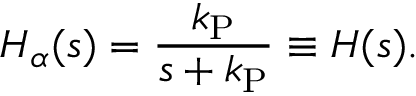<formula> <loc_0><loc_0><loc_500><loc_500>H _ { \alpha } ( s ) = \frac { k _ { P } } { s + k _ { P } } \equiv H ( s ) .</formula> 